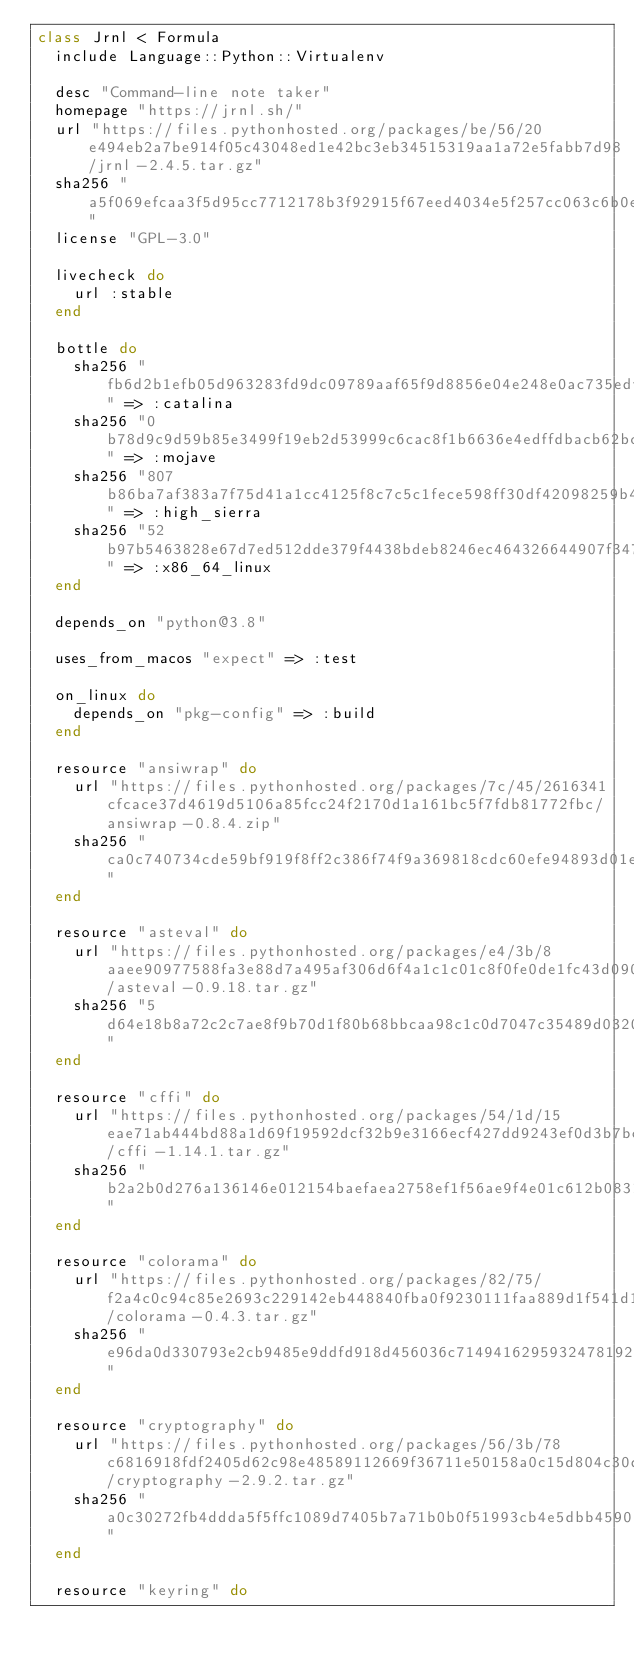Convert code to text. <code><loc_0><loc_0><loc_500><loc_500><_Ruby_>class Jrnl < Formula
  include Language::Python::Virtualenv

  desc "Command-line note taker"
  homepage "https://jrnl.sh/"
  url "https://files.pythonhosted.org/packages/be/56/20e494eb2a7be914f05c43048ed1e42bc3eb34515319aa1a72e5fabb7d98/jrnl-2.4.5.tar.gz"
  sha256 "a5f069efcaa3f5d95cc7712178b3f92915f67eed4034e5f257cc063c6b0e74d9"
  license "GPL-3.0"

  livecheck do
    url :stable
  end

  bottle do
    sha256 "fb6d2b1efb05d963283fd9dc09789aaf65f9d8856e04e248e0ac735edfc43613" => :catalina
    sha256 "0b78d9c9d59b85e3499f19eb2d53999c6cac8f1b6636e4edffdbacb62bc838b4" => :mojave
    sha256 "807b86ba7af383a7f75d41a1cc4125f8c7c5c1fece598ff30df42098259b4b79" => :high_sierra
    sha256 "52b97b5463828e67d7ed512dde379f4438bdeb8246ec464326644907f34735aa" => :x86_64_linux
  end

  depends_on "python@3.8"

  uses_from_macos "expect" => :test

  on_linux do
    depends_on "pkg-config" => :build
  end

  resource "ansiwrap" do
    url "https://files.pythonhosted.org/packages/7c/45/2616341cfcace37d4619d5106a85fcc24f2170d1a161bc5f7fdb81772fbc/ansiwrap-0.8.4.zip"
    sha256 "ca0c740734cde59bf919f8ff2c386f74f9a369818cdc60efe94893d01ea8d9b7"
  end

  resource "asteval" do
    url "https://files.pythonhosted.org/packages/e4/3b/8aaee90977588fa3e88d7a495af306d6f4a1c1c01c8f0fe0de1fc43d0908/asteval-0.9.18.tar.gz"
    sha256 "5d64e18b8a72c2c7ae8f9b70d1f80b68bbcaa98c1c0d7047c35489d03209bc86"
  end

  resource "cffi" do
    url "https://files.pythonhosted.org/packages/54/1d/15eae71ab444bd88a1d69f19592dcf32b9e3166ecf427dd9243ef0d3b7bc/cffi-1.14.1.tar.gz"
    sha256 "b2a2b0d276a136146e012154baefaea2758ef1f56ae9f4e01c612b0831e0bd2f"
  end

  resource "colorama" do
    url "https://files.pythonhosted.org/packages/82/75/f2a4c0c94c85e2693c229142eb448840fba0f9230111faa889d1f541d12d/colorama-0.4.3.tar.gz"
    sha256 "e96da0d330793e2cb9485e9ddfd918d456036c7149416295932478192f4436a1"
  end

  resource "cryptography" do
    url "https://files.pythonhosted.org/packages/56/3b/78c6816918fdf2405d62c98e48589112669f36711e50158a0c15d804c30d/cryptography-2.9.2.tar.gz"
    sha256 "a0c30272fb4ddda5f5ffc1089d7405b7a71b0b0f51993cb4e5dbb4590b2fc229"
  end

  resource "keyring" do</code> 